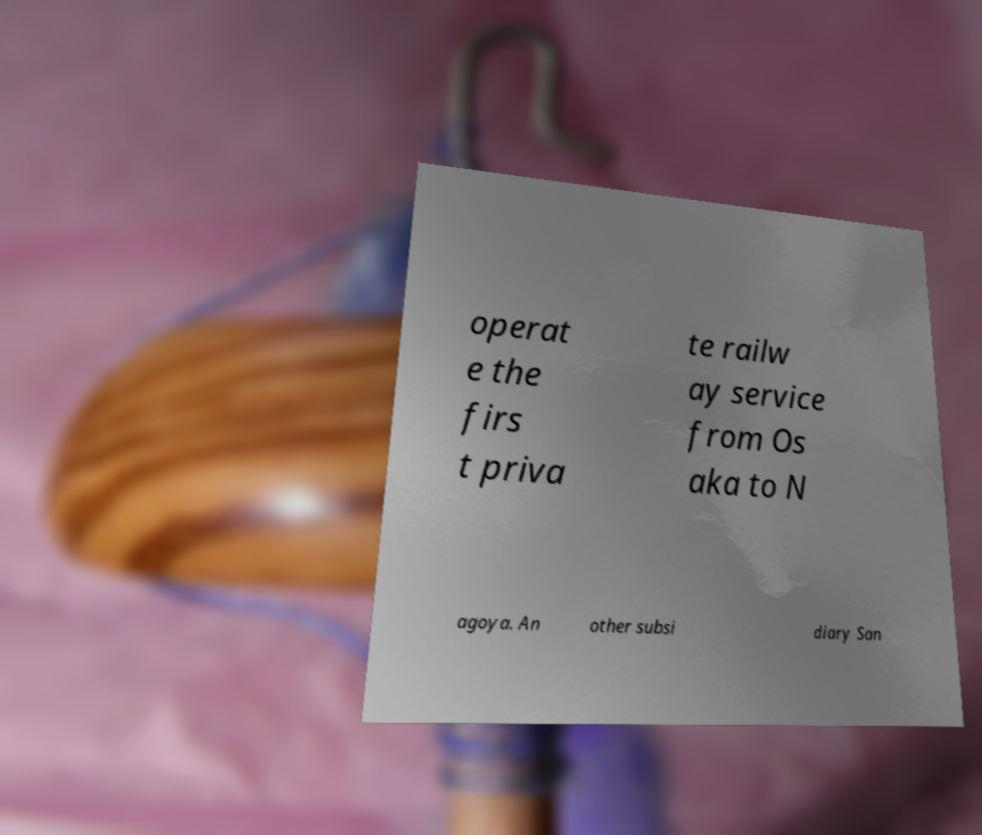What messages or text are displayed in this image? I need them in a readable, typed format. operat e the firs t priva te railw ay service from Os aka to N agoya. An other subsi diary San 